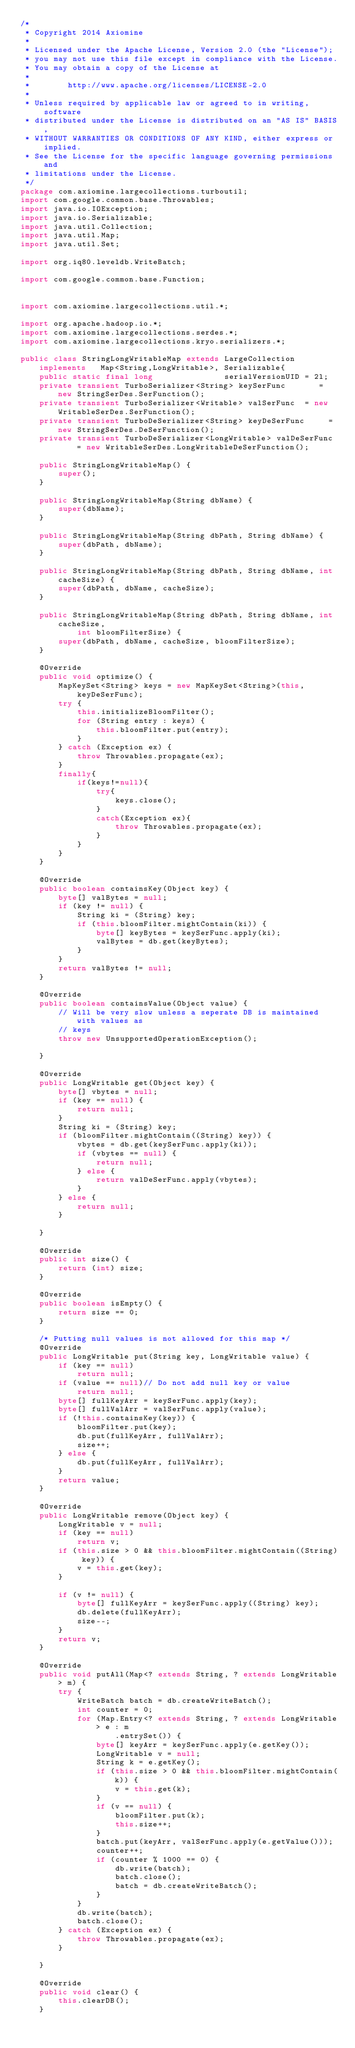<code> <loc_0><loc_0><loc_500><loc_500><_Java_>/*
 * Copyright 2014 Axiomine
 *
 * Licensed under the Apache License, Version 2.0 (the "License");
 * you may not use this file except in compliance with the License.
 * You may obtain a copy of the License at
 *
 *        http://www.apache.org/licenses/LICENSE-2.0
 *
 * Unless required by applicable law or agreed to in writing, software
 * distributed under the License is distributed on an "AS IS" BASIS,
 * WITHOUT WARRANTIES OR CONDITIONS OF ANY KIND, either express or implied.
 * See the License for the specific language governing permissions and
 * limitations under the License.
 */
package com.axiomine.largecollections.turboutil;
import com.google.common.base.Throwables;
import java.io.IOException;
import java.io.Serializable;
import java.util.Collection;
import java.util.Map;
import java.util.Set;

import org.iq80.leveldb.WriteBatch;

import com.google.common.base.Function;


import com.axiomine.largecollections.util.*;

import org.apache.hadoop.io.*;
import com.axiomine.largecollections.serdes.*;
import com.axiomine.largecollections.kryo.serializers.*;

public class StringLongWritableMap extends LargeCollection implements   Map<String,LongWritable>, Serializable{
    public static final long               serialVersionUID = 2l;
    private transient TurboSerializer<String> keySerFunc       = new StringSerDes.SerFunction();
    private transient TurboSerializer<Writable> valSerFunc  = new WritableSerDes.SerFunction();
    private transient TurboDeSerializer<String> keyDeSerFunc     = new StringSerDes.DeSerFunction();
    private transient TurboDeSerializer<LongWritable> valDeSerFunc     = new WritableSerDes.LongWritableDeSerFunction();
    
    public StringLongWritableMap() {
        super();
    }
    
    public StringLongWritableMap(String dbName) {
        super(dbName);
    }
    
    public StringLongWritableMap(String dbPath, String dbName) {
        super(dbPath, dbName);
    }
    
    public StringLongWritableMap(String dbPath, String dbName, int cacheSize) {
        super(dbPath, dbName, cacheSize);
    }
    
    public StringLongWritableMap(String dbPath, String dbName, int cacheSize,
            int bloomFilterSize) {
        super(dbPath, dbName, cacheSize, bloomFilterSize);
    }
    
    @Override
    public void optimize() {
        MapKeySet<String> keys = new MapKeySet<String>(this, keyDeSerFunc);
        try {
            this.initializeBloomFilter();
            for (String entry : keys) {
                this.bloomFilter.put(entry);
            }
        } catch (Exception ex) {
            throw Throwables.propagate(ex);
        }
        finally{
            if(keys!=null){
                try{
                    keys.close();
                }
                catch(Exception ex){
                    throw Throwables.propagate(ex);
                }                
            }
        }
    }
    
    @Override
    public boolean containsKey(Object key) {
        byte[] valBytes = null;
        if (key != null) {
            String ki = (String) key;
            if (this.bloomFilter.mightContain(ki)) {
                byte[] keyBytes = keySerFunc.apply(ki);
                valBytes = db.get(keyBytes);
            }
        }
        return valBytes != null;
    }
    
    @Override
    public boolean containsValue(Object value) {
        // Will be very slow unless a seperate DB is maintained with values as
        // keys
        throw new UnsupportedOperationException();
        
    }
    
    @Override
    public LongWritable get(Object key) {
        byte[] vbytes = null;
        if (key == null) {
            return null;
        }
        String ki = (String) key;
        if (bloomFilter.mightContain((String) key)) {
            vbytes = db.get(keySerFunc.apply(ki));
            if (vbytes == null) {
                return null;
            } else {
                return valDeSerFunc.apply(vbytes);
            }
        } else {
            return null;
        }
        
    }
    
    @Override
    public int size() {
        return (int) size;
    }
    
    @Override
    public boolean isEmpty() {
        return size == 0;
    }
    
    /* Putting null values is not allowed for this map */
    @Override
    public LongWritable put(String key, LongWritable value) {
        if (key == null)
            return null;
        if (value == null)// Do not add null key or value
            return null;
        byte[] fullKeyArr = keySerFunc.apply(key);
        byte[] fullValArr = valSerFunc.apply(value);
        if (!this.containsKey(key)) {
            bloomFilter.put(key);
            db.put(fullKeyArr, fullValArr);
            size++;
        } else {
            db.put(fullKeyArr, fullValArr);
        }
        return value;
    }
    
    @Override
    public LongWritable remove(Object key) {
        LongWritable v = null;
        if (key == null)
            return v;
        if (this.size > 0 && this.bloomFilter.mightContain((String) key)) {
            v = this.get(key);
        }
        
        if (v != null) {
            byte[] fullKeyArr = keySerFunc.apply((String) key);
            db.delete(fullKeyArr);
            size--;
        }
        return v;
    }
    
    @Override
    public void putAll(Map<? extends String, ? extends LongWritable> m) {
        try {
            WriteBatch batch = db.createWriteBatch();
            int counter = 0;
            for (Map.Entry<? extends String, ? extends LongWritable> e : m
                    .entrySet()) {
                byte[] keyArr = keySerFunc.apply(e.getKey());
                LongWritable v = null;
                String k = e.getKey();
                if (this.size > 0 && this.bloomFilter.mightContain(k)) {
                    v = this.get(k);
                }
                if (v == null) {
                    bloomFilter.put(k);
                    this.size++;
                }
                batch.put(keyArr, valSerFunc.apply(e.getValue()));
                counter++;
                if (counter % 1000 == 0) {
                    db.write(batch);
                    batch.close();
                    batch = db.createWriteBatch();
                }
            }
            db.write(batch);
            batch.close();
        } catch (Exception ex) {
            throw Throwables.propagate(ex);
        }
        
    }
    
    @Override
    public void clear() {
        this.clearDB();
    }
    </code> 